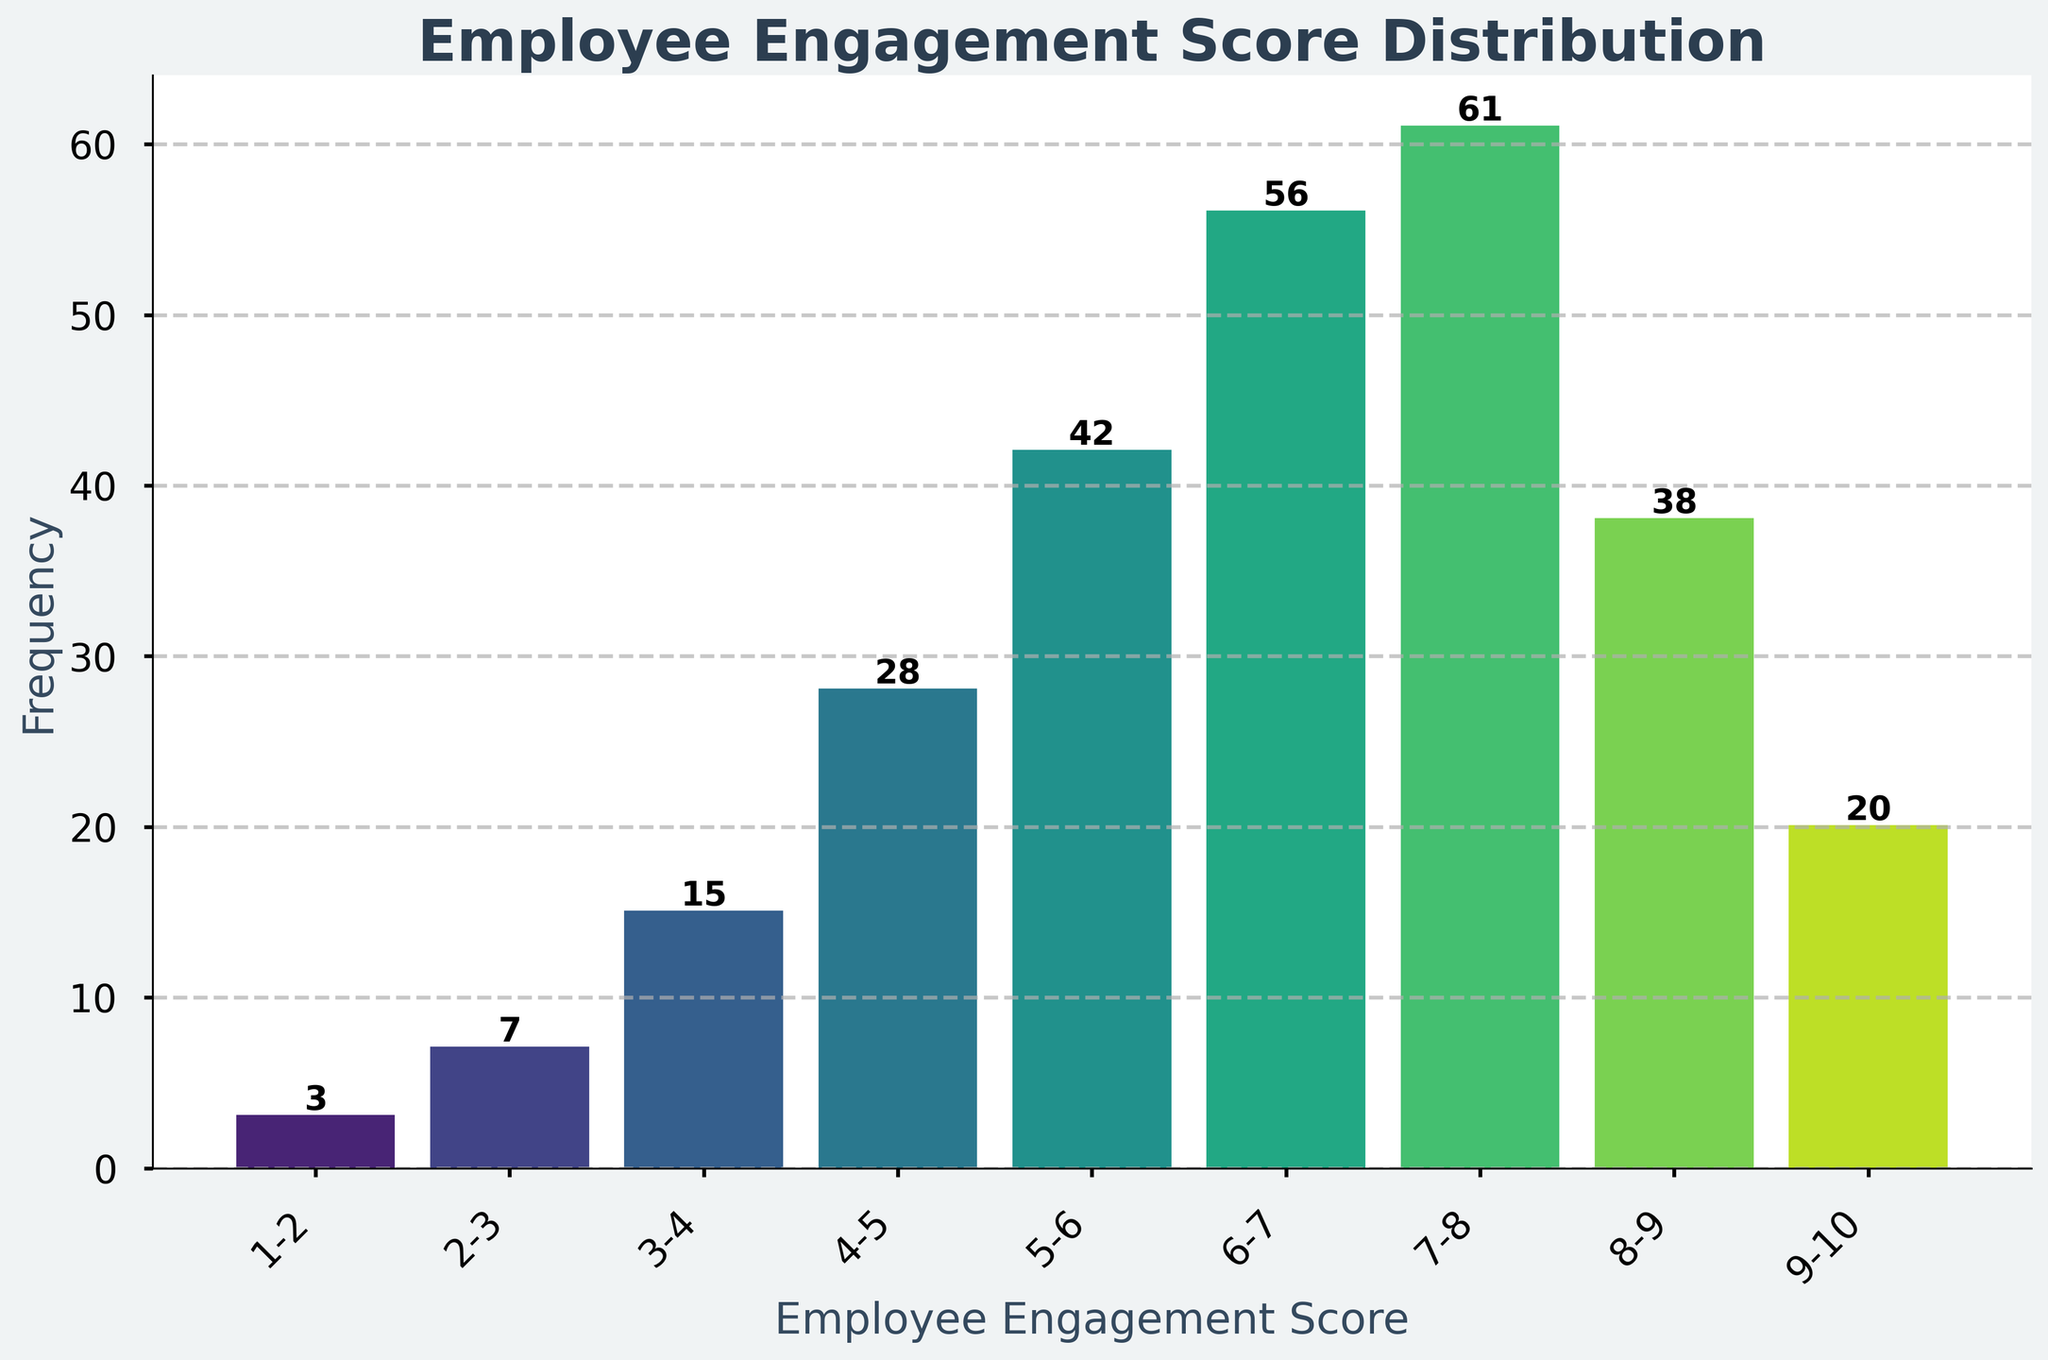What is the title of the histogram? The title is displayed prominently at the top of the histogram.
Answer: Employee Engagement Score Distribution What does the x-axis represent? The x-axis represents the range of Employee Engagement Scores. This is indicated by the label.
Answer: Employee Engagement Score What is the frequency of scores in the range 6-7? By looking at the bar labelled 6-7, the number above it indicates the frequency.
Answer: 56 Which score range has the highest frequency? By comparing the heights of all bars, the tallest one indicates the highest frequency.
Answer: 7-8 What is the sum of frequencies for scores 1-2 and 2-3? Adding the frequencies of 1-2 (3) and 2-3 (7) gives 3 + 7.
Answer: 10 How does the frequency of scores in the 8-9 range compare to those in the 9-10 range? Looking at the heights and checking the values above the bars, 8-9 has 38 and 9-10 has 20, so 38 is greater than 20.
Answer: Higher What are the frequencies of the two most common score ranges combined? The two most common ranges are 7-8 (61) and 6-7 (56). Adding these values yields 117.
Answer: 117 Which score range has the lowest frequency? Looking for the shortest bar indicates that 1-2 has 3, the lowest frequency.
Answer: 1-2 What's the average frequency of score ranges from 4-5 to 9-10? Summing the frequencies (28, 42, 56, 61, 38, 20) and dividing by the number of ranges (6), gives (28+42+56+61+38+20)/6 = 40.83 (rounded to two decimal places).
Answer: 40.83 How many score ranges have a frequency greater than 50? Counting the bars with a frequency above 50: 6-7 (56) and 7-8 (61), gives a total of 2 ranges.
Answer: 2 